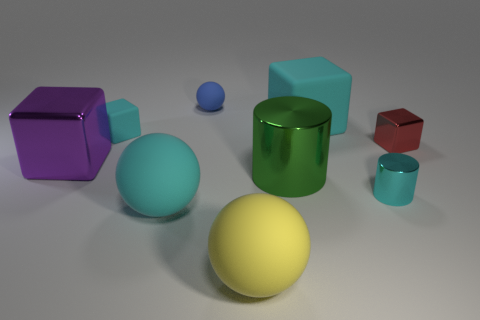Add 1 large cyan rubber objects. How many objects exist? 10 Subtract all balls. How many objects are left? 6 Add 3 yellow objects. How many yellow objects exist? 4 Subtract 0 blue cylinders. How many objects are left? 9 Subtract all red metallic cylinders. Subtract all yellow matte spheres. How many objects are left? 8 Add 1 red shiny cubes. How many red shiny cubes are left? 2 